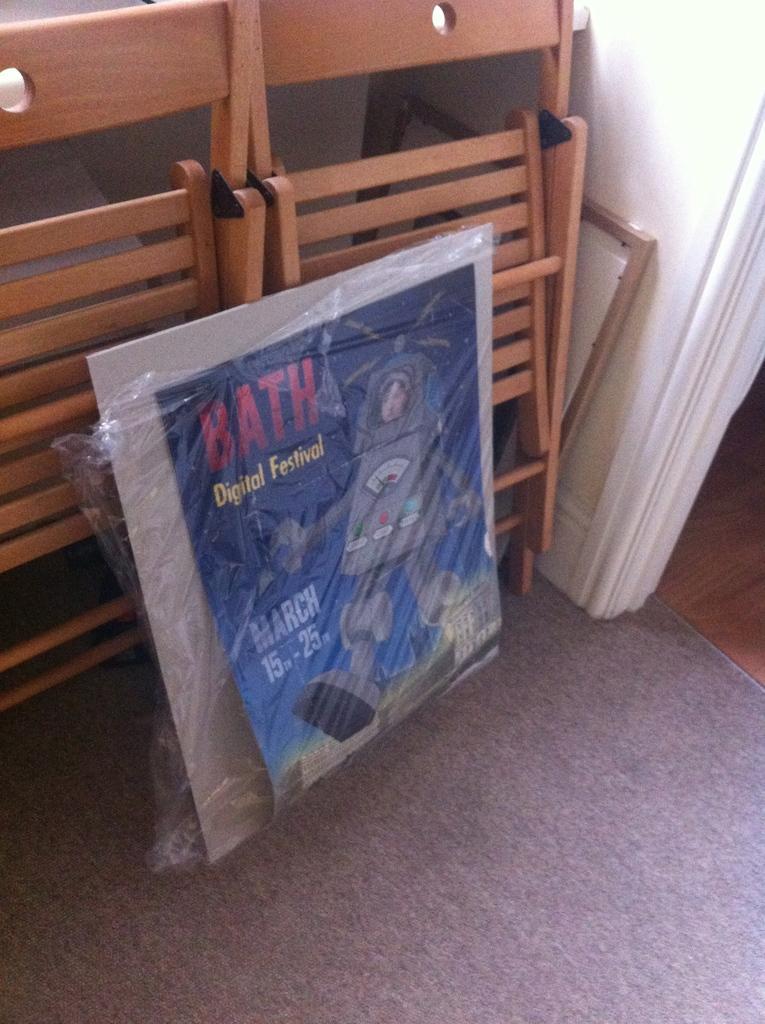Can you describe this image briefly? In this image we can see a poster, wooden objects and wall. We can see the carpet at the bottom of the image. 